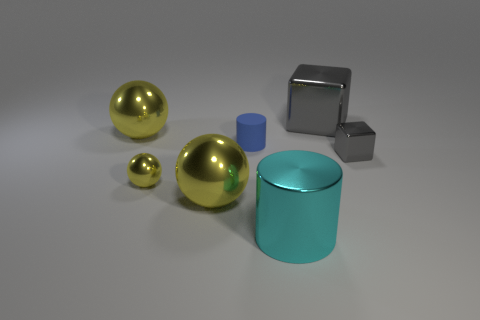Add 1 green metal cubes. How many objects exist? 8 Subtract all small metal spheres. How many spheres are left? 2 Add 7 small cubes. How many small cubes are left? 8 Add 4 tiny yellow metallic balls. How many tiny yellow metallic balls exist? 5 Subtract 0 green cylinders. How many objects are left? 7 Subtract all balls. How many objects are left? 4 Subtract all cyan cylinders. Subtract all purple blocks. How many cylinders are left? 1 Subtract all cyan things. Subtract all tiny yellow shiny things. How many objects are left? 5 